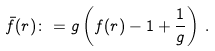<formula> <loc_0><loc_0><loc_500><loc_500>\bar { f } ( r ) \colon = g \left ( f ( r ) - 1 + \frac { 1 } { g } \right ) \, .</formula> 